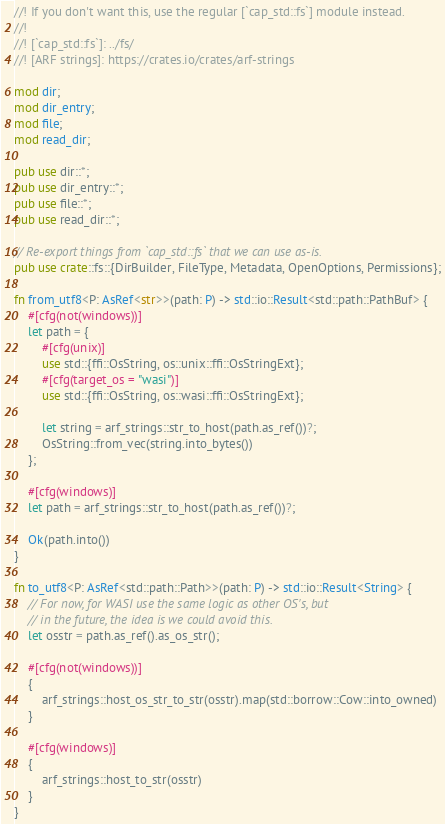Convert code to text. <code><loc_0><loc_0><loc_500><loc_500><_Rust_>//! If you don't want this, use the regular [`cap_std::fs`] module instead.
//!
//! [`cap_std::fs`]: ../fs/
//! [ARF strings]: https://crates.io/crates/arf-strings

mod dir;
mod dir_entry;
mod file;
mod read_dir;

pub use dir::*;
pub use dir_entry::*;
pub use file::*;
pub use read_dir::*;

// Re-export things from `cap_std::fs` that we can use as-is.
pub use crate::fs::{DirBuilder, FileType, Metadata, OpenOptions, Permissions};

fn from_utf8<P: AsRef<str>>(path: P) -> std::io::Result<std::path::PathBuf> {
    #[cfg(not(windows))]
    let path = {
        #[cfg(unix)]
        use std::{ffi::OsString, os::unix::ffi::OsStringExt};
        #[cfg(target_os = "wasi")]
        use std::{ffi::OsString, os::wasi::ffi::OsStringExt};

        let string = arf_strings::str_to_host(path.as_ref())?;
        OsString::from_vec(string.into_bytes())
    };

    #[cfg(windows)]
    let path = arf_strings::str_to_host(path.as_ref())?;

    Ok(path.into())
}

fn to_utf8<P: AsRef<std::path::Path>>(path: P) -> std::io::Result<String> {
    // For now, for WASI use the same logic as other OS's, but
    // in the future, the idea is we could avoid this.
    let osstr = path.as_ref().as_os_str();

    #[cfg(not(windows))]
    {
        arf_strings::host_os_str_to_str(osstr).map(std::borrow::Cow::into_owned)
    }

    #[cfg(windows)]
    {
        arf_strings::host_to_str(osstr)
    }
}
</code> 